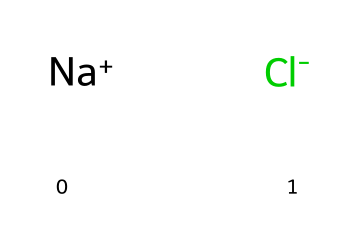What is the name of the ionic compound represented? The SMILES representation shows sodium (Na) and chloride (Cl) ions, indicating that the compound is sodium chloride.
Answer: sodium chloride How many atoms are present in this chemical? The SMILES notation indicates one sodium atom and one chloride atom, totaling two atoms in this ionic compound.
Answer: 2 How does this chemical dissociate in water? Sodium chloride dissociates into sodium ions and chloride ions when it dissolves in water, which occurs because it is an ionic compound.
Answer: into ions What type of bond is present in this chemical? The bond between sodium and chloride ions is an ionic bond, which is formed by the electrostatic attraction between positively charged sodium ions and negatively charged chloride ions.
Answer: ionic bond What is the effect of this chemical on the environment when used as a de-icing agent? Sodium chloride can lead to increased salinity in water bodies, disrupting aquatic ecosystems due to toxicity in high concentrations.
Answer: salinity What is the main benefit of using sodium chloride for de-icing? The primary benefit of sodium chloride is its effectiveness in lowering the freezing point of water, thus preventing ice formation on roads and improving safety during winter.
Answer: effectiveness How does sodium chloride impact soil health? When sodium chloride accumulates in soil, it can lead to reduced soil fertility and hinder plant growth due to osmotic stress.
Answer: reduced fertility 